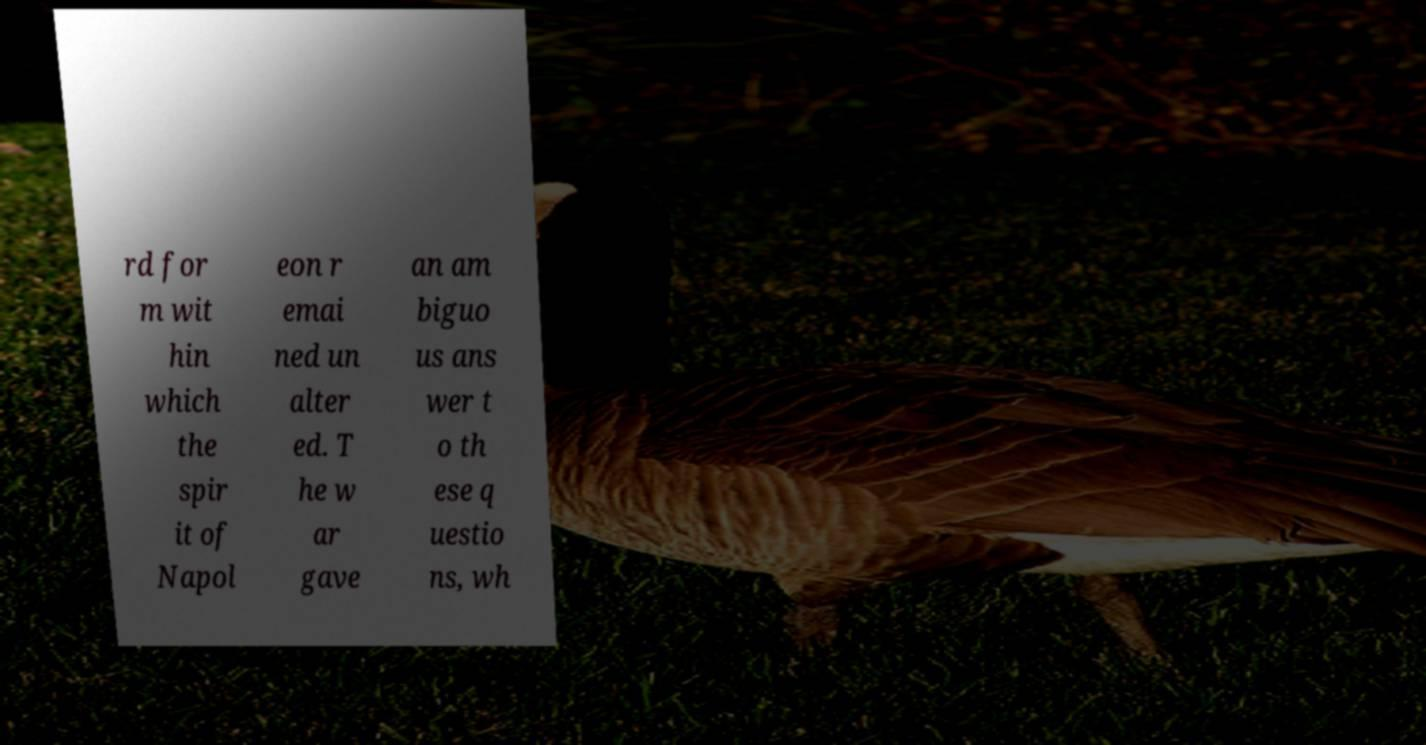Could you assist in decoding the text presented in this image and type it out clearly? rd for m wit hin which the spir it of Napol eon r emai ned un alter ed. T he w ar gave an am biguo us ans wer t o th ese q uestio ns, wh 